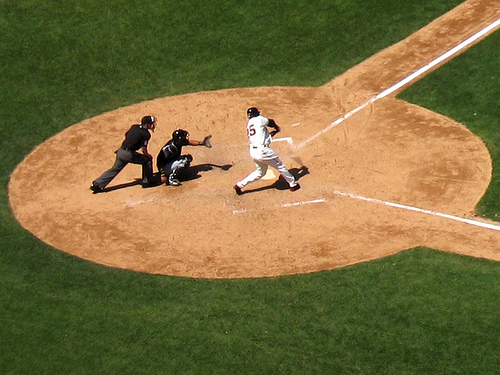Read all the text in this image. 5 